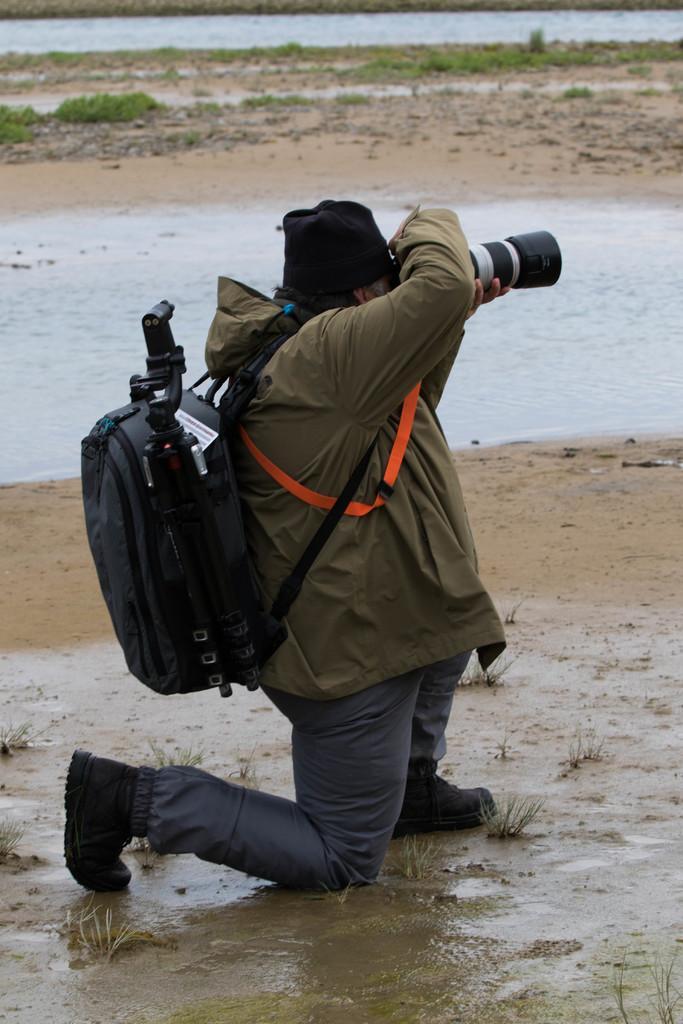Could you give a brief overview of what you see in this image? In this image I can see a person holding a camera and wearing a bag. In the background I can see water and grasses on ground. 